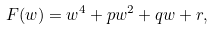Convert formula to latex. <formula><loc_0><loc_0><loc_500><loc_500>F ( w ) = w ^ { 4 } + p w ^ { 2 } + q w + r ,</formula> 